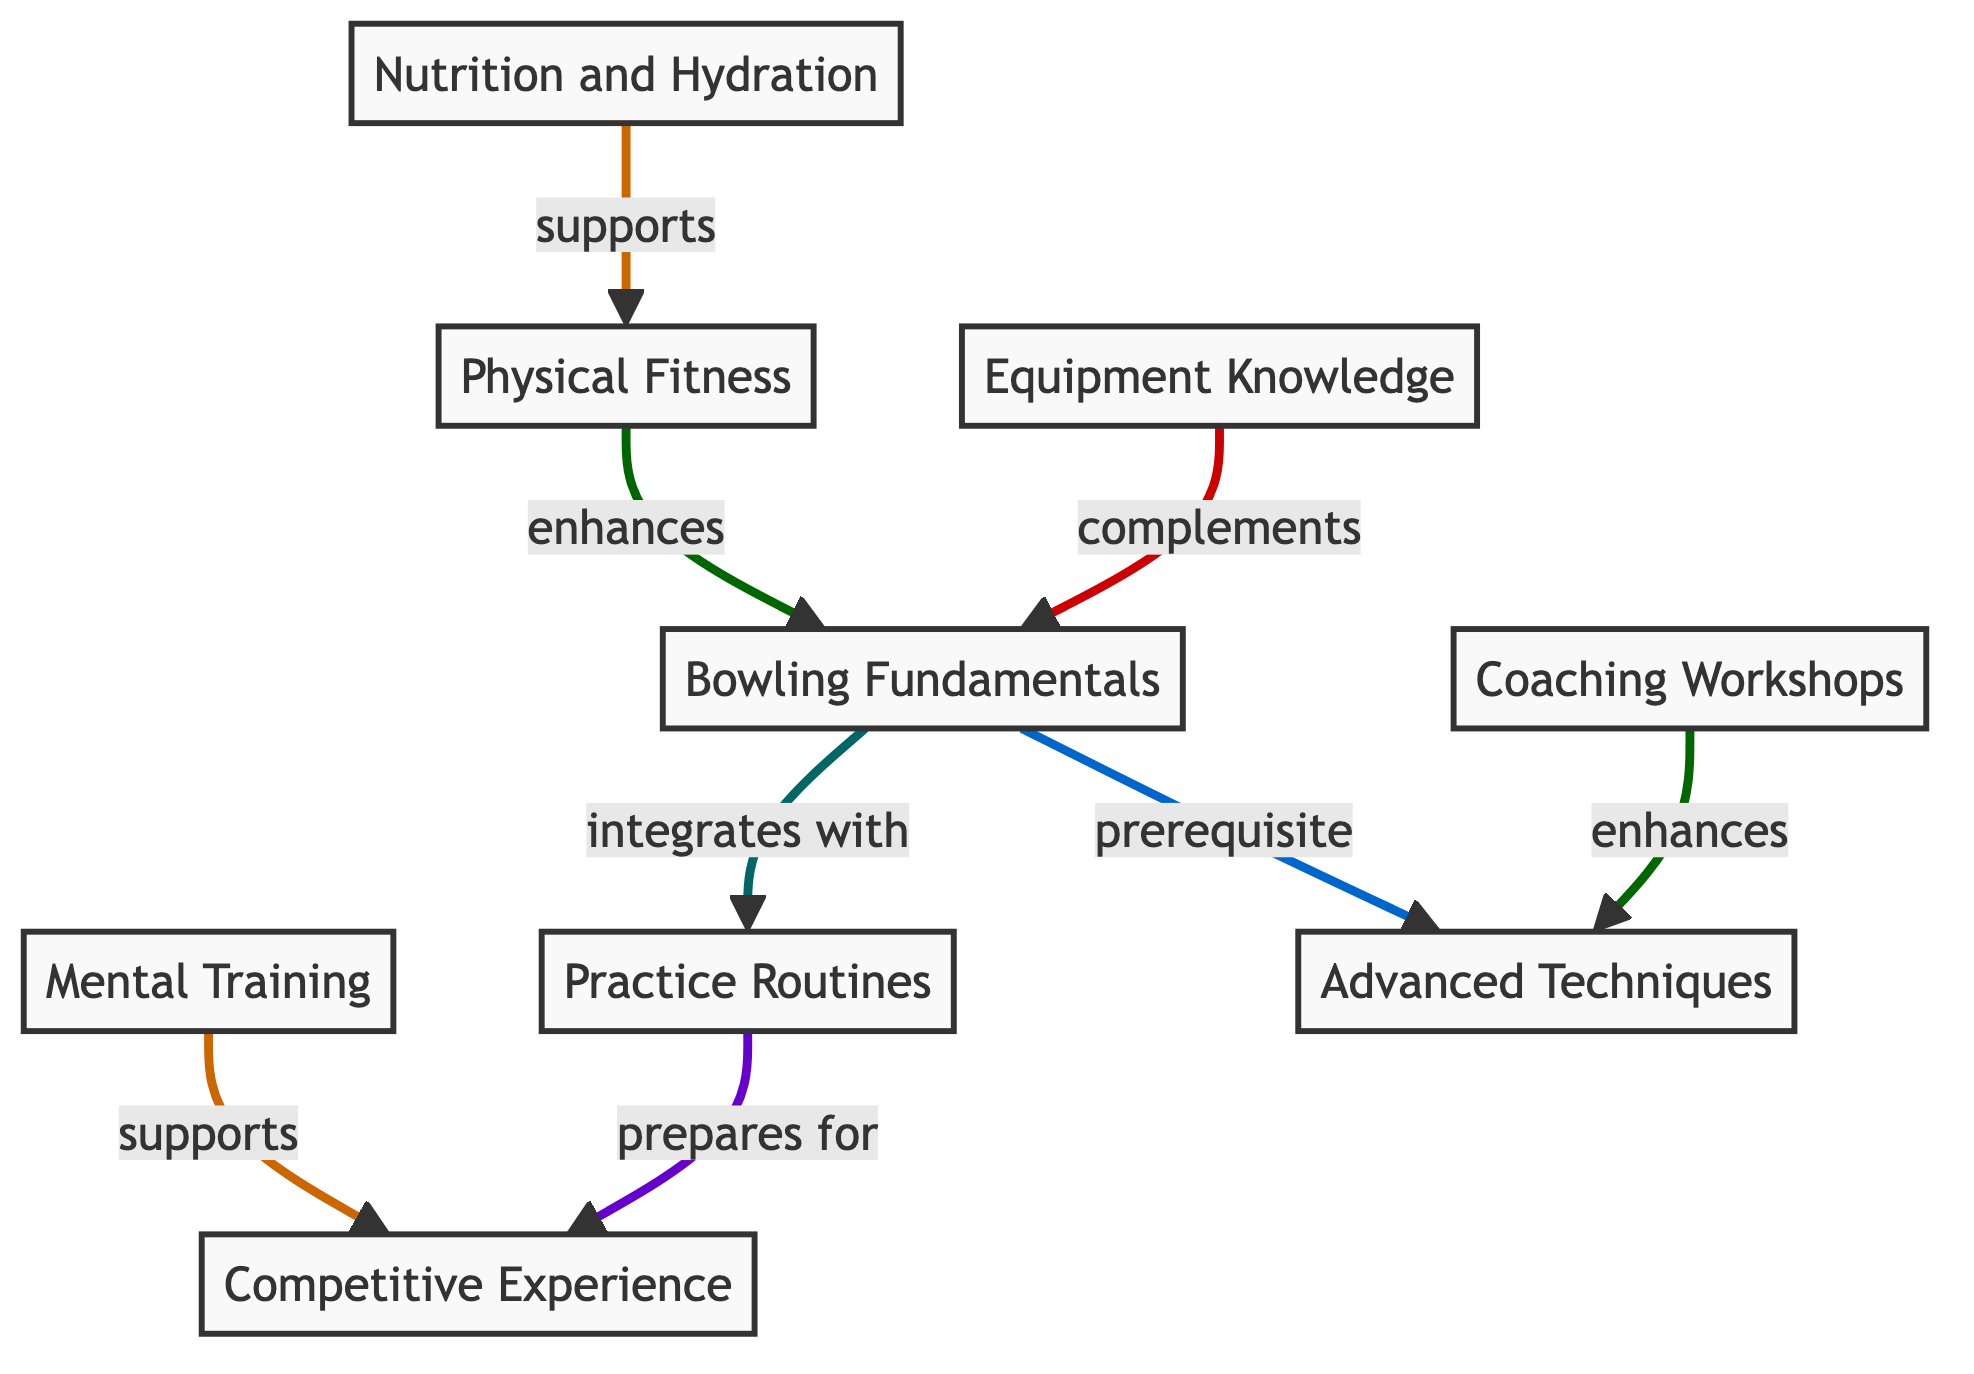What is the total number of nodes in the diagram? The diagram has eight nodes representing different components of skill development for youth bowlers.
Answer: 8 What is the relationship between Physical Fitness and Bowling Fundamentals? The relationship is that Physical Fitness enhances the Bowling Fundamentals, helping to develop those skills more effectively.
Answer: enhances Which node is a prerequisite for Advanced Techniques? The prerequisite node for Advanced Techniques is Bowling Fundamentals, as it lays the foundation for learning advanced skills.
Answer: Bowling Fundamentals How many nodes support Competitive Experience? Two nodes support Competitive Experience: Mental Training and Practice Routines, which both contribute to preparing for competitive scenarios.
Answer: 2 What does Equipment Knowledge complement? Equipment Knowledge complements Bowling Fundamentals, providing essential background on the tools used in bowling to improve technique.
Answer: Bowling Fundamentals Which nodes integrate with Practice Routines? The only node that integrates with Practice Routines is Bowling Fundamentals, indicating that practicing these fundamentals enhances the routines.
Answer: Bowling Fundamentals What type of relationship exists between Mental Training and Competitive Experience? The relationship is that Mental Training supports Competitive Experience, suggesting that a strong mental game is essential in competitions.
Answer: supports Which area of skill development does Nutrition and Hydration support? Nutrition and Hydration support Physical Fitness, indicating that proper nutrition aids in overall physical conditioning for bowlers.
Answer: Physical Fitness How many relationships are represented in the diagram? There are eight relationships depicted in the diagram, linking the various nodes and showing their interconnections.
Answer: 8 